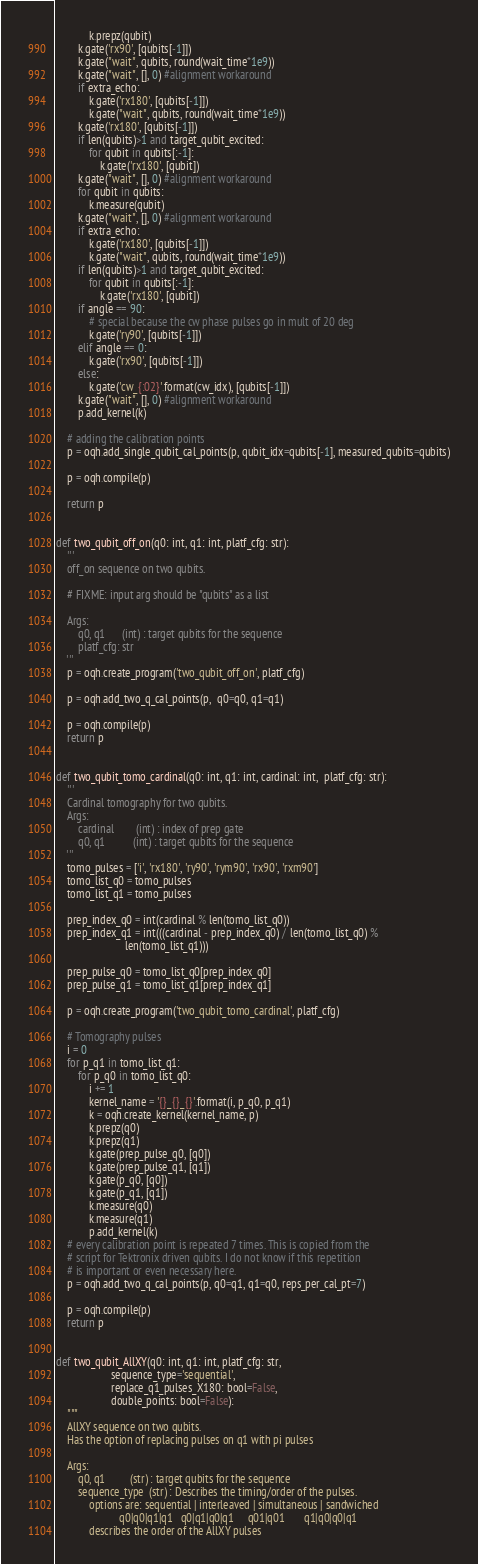<code> <loc_0><loc_0><loc_500><loc_500><_Python_>            k.prepz(qubit)
        k.gate('rx90', [qubits[-1]])
        k.gate("wait", qubits, round(wait_time*1e9))
        k.gate("wait", [], 0) #alignment workaround
        if extra_echo:
            k.gate('rx180', [qubits[-1]])
            k.gate("wait", qubits, round(wait_time*1e9))
        k.gate('rx180', [qubits[-1]])
        if len(qubits)>1 and target_qubit_excited:
            for qubit in qubits[:-1]:
                k.gate('rx180', [qubit])
        k.gate("wait", [], 0) #alignment workaround
        for qubit in qubits:
            k.measure(qubit)
        k.gate("wait", [], 0) #alignment workaround
        if extra_echo:
            k.gate('rx180', [qubits[-1]])
            k.gate("wait", qubits, round(wait_time*1e9))
        if len(qubits)>1 and target_qubit_excited:
            for qubit in qubits[:-1]:
                k.gate('rx180', [qubit])
        if angle == 90:
            # special because the cw phase pulses go in mult of 20 deg
            k.gate('ry90', [qubits[-1]])
        elif angle == 0:
            k.gate('rx90', [qubits[-1]])
        else:
            k.gate('cw_{:02}'.format(cw_idx), [qubits[-1]])
        k.gate("wait", [], 0) #alignment workaround
        p.add_kernel(k)

    # adding the calibration points
    p = oqh.add_single_qubit_cal_points(p, qubit_idx=qubits[-1], measured_qubits=qubits)

    p = oqh.compile(p)

    return p


def two_qubit_off_on(q0: int, q1: int, platf_cfg: str):
    '''
    off_on sequence on two qubits.

    # FIXME: input arg should be "qubits" as a list

    Args:
        q0, q1      (int) : target qubits for the sequence
        platf_cfg: str
    '''
    p = oqh.create_program('two_qubit_off_on', platf_cfg)

    p = oqh.add_two_q_cal_points(p,  q0=q0, q1=q1)

    p = oqh.compile(p)
    return p


def two_qubit_tomo_cardinal(q0: int, q1: int, cardinal: int,  platf_cfg: str):
    '''
    Cardinal tomography for two qubits.
    Args:
        cardinal        (int) : index of prep gate
        q0, q1          (int) : target qubits for the sequence
    '''
    tomo_pulses = ['i', 'rx180', 'ry90', 'rym90', 'rx90', 'rxm90']
    tomo_list_q0 = tomo_pulses
    tomo_list_q1 = tomo_pulses

    prep_index_q0 = int(cardinal % len(tomo_list_q0))
    prep_index_q1 = int(((cardinal - prep_index_q0) / len(tomo_list_q0) %
                         len(tomo_list_q1)))

    prep_pulse_q0 = tomo_list_q0[prep_index_q0]
    prep_pulse_q1 = tomo_list_q1[prep_index_q1]

    p = oqh.create_program('two_qubit_tomo_cardinal', platf_cfg)

    # Tomography pulses
    i = 0
    for p_q1 in tomo_list_q1:
        for p_q0 in tomo_list_q0:
            i += 1
            kernel_name = '{}_{}_{}'.format(i, p_q0, p_q1)
            k = oqh.create_kernel(kernel_name, p)
            k.prepz(q0)
            k.prepz(q1)
            k.gate(prep_pulse_q0, [q0])
            k.gate(prep_pulse_q1, [q1])
            k.gate(p_q0, [q0])
            k.gate(p_q1, [q1])
            k.measure(q0)
            k.measure(q1)
            p.add_kernel(k)
    # every calibration point is repeated 7 times. This is copied from the
    # script for Tektronix driven qubits. I do not know if this repetition
    # is important or even necessary here.
    p = oqh.add_two_q_cal_points(p, q0=q1, q1=q0, reps_per_cal_pt=7)

    p = oqh.compile(p)
    return p


def two_qubit_AllXY(q0: int, q1: int, platf_cfg: str,
                    sequence_type='sequential',
                    replace_q1_pulses_X180: bool=False,
                    double_points: bool=False):
    """
    AllXY sequence on two qubits.
    Has the option of replacing pulses on q1 with pi pulses

    Args:
        q0, q1         (str) : target qubits for the sequence
        sequence_type  (str) : Describes the timing/order of the pulses.
            options are: sequential | interleaved | simultaneous | sandwiched
                       q0|q0|q1|q1   q0|q1|q0|q1     q01|q01       q1|q0|q0|q1
            describes the order of the AllXY pulses</code> 